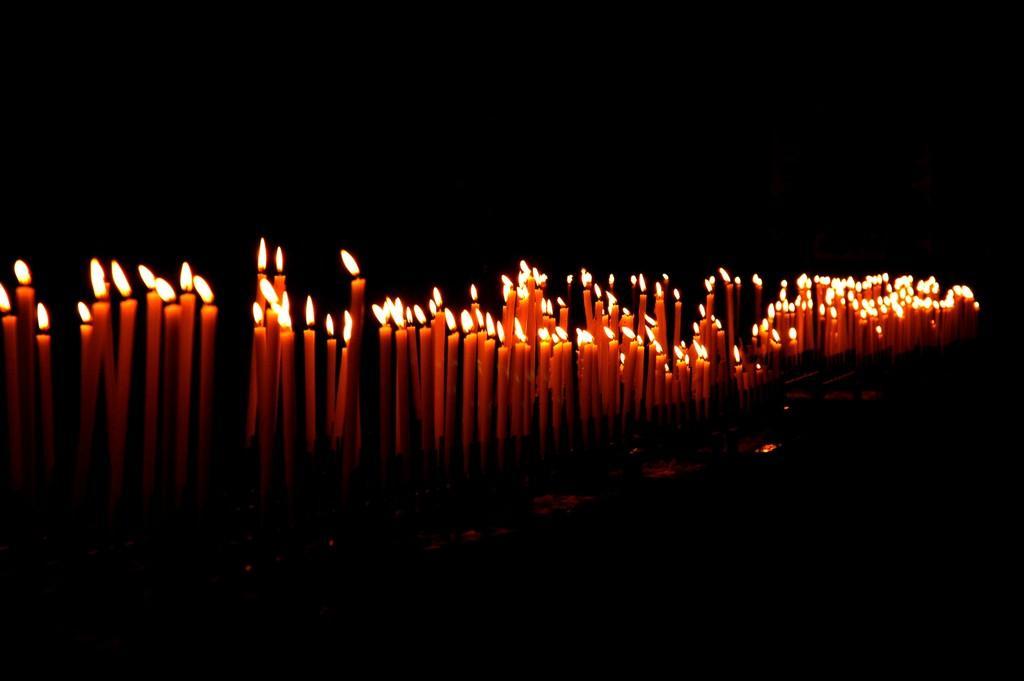Please provide a concise description of this image. In this image we can see some candles, and the background is dark. 